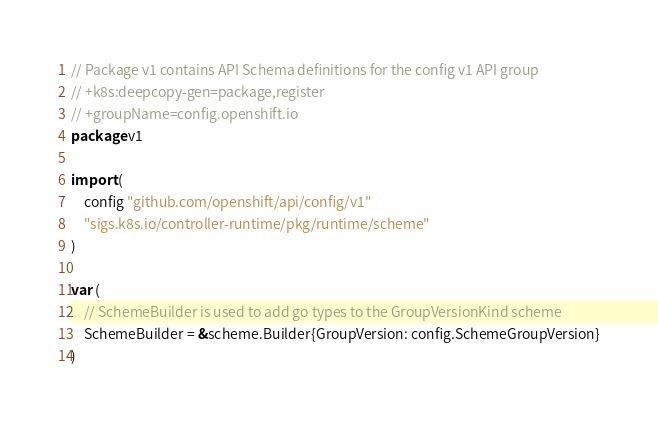<code> <loc_0><loc_0><loc_500><loc_500><_Go_>// Package v1 contains API Schema definitions for the config v1 API group
// +k8s:deepcopy-gen=package,register
// +groupName=config.openshift.io
package v1

import (
	config "github.com/openshift/api/config/v1"
	"sigs.k8s.io/controller-runtime/pkg/runtime/scheme"
)

var (
	// SchemeBuilder is used to add go types to the GroupVersionKind scheme
	SchemeBuilder = &scheme.Builder{GroupVersion: config.SchemeGroupVersion}
)
</code> 